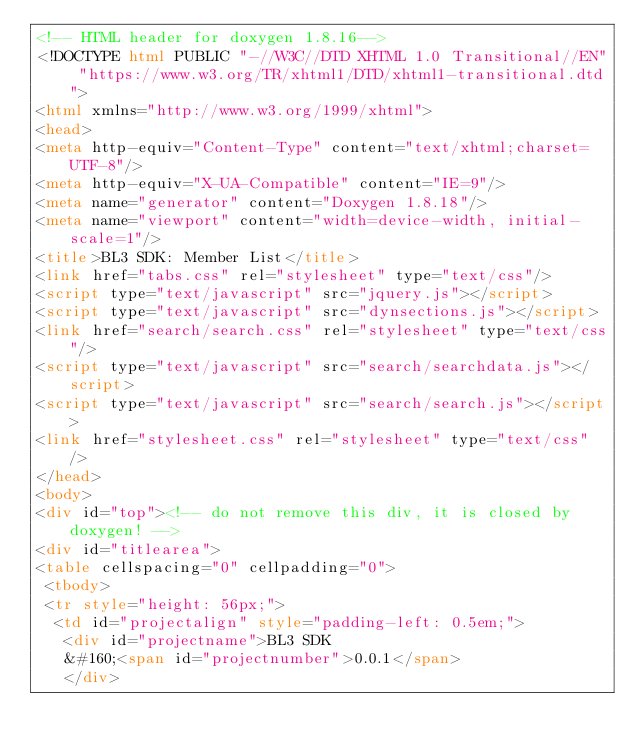<code> <loc_0><loc_0><loc_500><loc_500><_HTML_><!-- HTML header for doxygen 1.8.16-->
<!DOCTYPE html PUBLIC "-//W3C//DTD XHTML 1.0 Transitional//EN" "https://www.w3.org/TR/xhtml1/DTD/xhtml1-transitional.dtd">
<html xmlns="http://www.w3.org/1999/xhtml">
<head>
<meta http-equiv="Content-Type" content="text/xhtml;charset=UTF-8"/>
<meta http-equiv="X-UA-Compatible" content="IE=9"/>
<meta name="generator" content="Doxygen 1.8.18"/>
<meta name="viewport" content="width=device-width, initial-scale=1"/>
<title>BL3 SDK: Member List</title>
<link href="tabs.css" rel="stylesheet" type="text/css"/>
<script type="text/javascript" src="jquery.js"></script>
<script type="text/javascript" src="dynsections.js"></script>
<link href="search/search.css" rel="stylesheet" type="text/css"/>
<script type="text/javascript" src="search/searchdata.js"></script>
<script type="text/javascript" src="search/search.js"></script>
<link href="stylesheet.css" rel="stylesheet" type="text/css" />
</head>
<body>
<div id="top"><!-- do not remove this div, it is closed by doxygen! -->
<div id="titlearea">
<table cellspacing="0" cellpadding="0">
 <tbody>
 <tr style="height: 56px;">
  <td id="projectalign" style="padding-left: 0.5em;">
   <div id="projectname">BL3 SDK
   &#160;<span id="projectnumber">0.0.1</span>
   </div></code> 